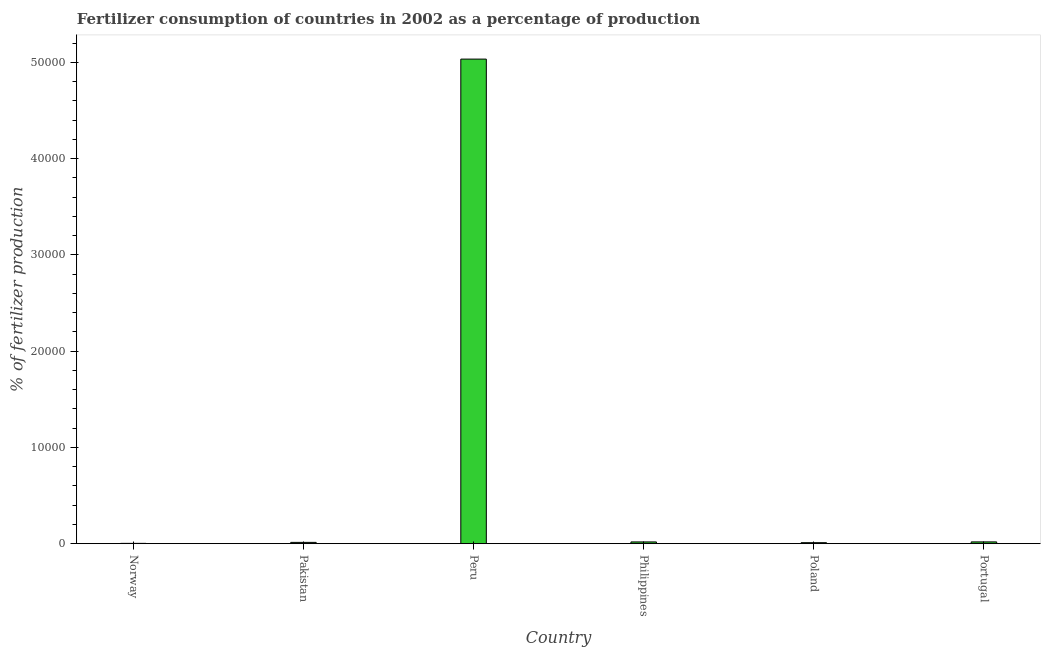What is the title of the graph?
Give a very brief answer. Fertilizer consumption of countries in 2002 as a percentage of production. What is the label or title of the X-axis?
Provide a succinct answer. Country. What is the label or title of the Y-axis?
Give a very brief answer. % of fertilizer production. What is the amount of fertilizer consumption in Norway?
Your answer should be compact. 30.19. Across all countries, what is the maximum amount of fertilizer consumption?
Your answer should be compact. 5.03e+04. Across all countries, what is the minimum amount of fertilizer consumption?
Your answer should be compact. 30.19. In which country was the amount of fertilizer consumption minimum?
Your answer should be very brief. Norway. What is the sum of the amount of fertilizer consumption?
Ensure brevity in your answer.  5.10e+04. What is the difference between the amount of fertilizer consumption in Norway and Portugal?
Your response must be concise. -152.18. What is the average amount of fertilizer consumption per country?
Make the answer very short. 8493.97. What is the median amount of fertilizer consumption?
Your answer should be very brief. 156.02. In how many countries, is the amount of fertilizer consumption greater than 38000 %?
Your answer should be very brief. 1. What is the ratio of the amount of fertilizer consumption in Pakistan to that in Peru?
Give a very brief answer. 0. Is the amount of fertilizer consumption in Philippines less than that in Poland?
Give a very brief answer. No. What is the difference between the highest and the second highest amount of fertilizer consumption?
Your answer should be very brief. 5.02e+04. Is the sum of the amount of fertilizer consumption in Philippines and Portugal greater than the maximum amount of fertilizer consumption across all countries?
Provide a succinct answer. No. What is the difference between the highest and the lowest amount of fertilizer consumption?
Provide a short and direct response. 5.03e+04. In how many countries, is the amount of fertilizer consumption greater than the average amount of fertilizer consumption taken over all countries?
Your answer should be very brief. 1. Are all the bars in the graph horizontal?
Provide a short and direct response. No. What is the difference between two consecutive major ticks on the Y-axis?
Make the answer very short. 10000. What is the % of fertilizer production in Norway?
Offer a very short reply. 30.19. What is the % of fertilizer production in Pakistan?
Your response must be concise. 132.13. What is the % of fertilizer production in Peru?
Make the answer very short. 5.03e+04. What is the % of fertilizer production of Philippines?
Provide a succinct answer. 179.9. What is the % of fertilizer production of Poland?
Provide a short and direct response. 102.4. What is the % of fertilizer production of Portugal?
Ensure brevity in your answer.  182.38. What is the difference between the % of fertilizer production in Norway and Pakistan?
Keep it short and to the point. -101.94. What is the difference between the % of fertilizer production in Norway and Peru?
Give a very brief answer. -5.03e+04. What is the difference between the % of fertilizer production in Norway and Philippines?
Your response must be concise. -149.71. What is the difference between the % of fertilizer production in Norway and Poland?
Your response must be concise. -72.21. What is the difference between the % of fertilizer production in Norway and Portugal?
Your answer should be compact. -152.18. What is the difference between the % of fertilizer production in Pakistan and Peru?
Provide a succinct answer. -5.02e+04. What is the difference between the % of fertilizer production in Pakistan and Philippines?
Your response must be concise. -47.77. What is the difference between the % of fertilizer production in Pakistan and Poland?
Provide a short and direct response. 29.73. What is the difference between the % of fertilizer production in Pakistan and Portugal?
Offer a very short reply. -50.24. What is the difference between the % of fertilizer production in Peru and Philippines?
Your answer should be compact. 5.02e+04. What is the difference between the % of fertilizer production in Peru and Poland?
Make the answer very short. 5.02e+04. What is the difference between the % of fertilizer production in Peru and Portugal?
Offer a terse response. 5.02e+04. What is the difference between the % of fertilizer production in Philippines and Poland?
Offer a terse response. 77.5. What is the difference between the % of fertilizer production in Philippines and Portugal?
Provide a short and direct response. -2.48. What is the difference between the % of fertilizer production in Poland and Portugal?
Provide a short and direct response. -79.97. What is the ratio of the % of fertilizer production in Norway to that in Pakistan?
Offer a terse response. 0.23. What is the ratio of the % of fertilizer production in Norway to that in Peru?
Offer a very short reply. 0. What is the ratio of the % of fertilizer production in Norway to that in Philippines?
Ensure brevity in your answer.  0.17. What is the ratio of the % of fertilizer production in Norway to that in Poland?
Make the answer very short. 0.29. What is the ratio of the % of fertilizer production in Norway to that in Portugal?
Your response must be concise. 0.17. What is the ratio of the % of fertilizer production in Pakistan to that in Peru?
Your response must be concise. 0. What is the ratio of the % of fertilizer production in Pakistan to that in Philippines?
Your response must be concise. 0.73. What is the ratio of the % of fertilizer production in Pakistan to that in Poland?
Provide a succinct answer. 1.29. What is the ratio of the % of fertilizer production in Pakistan to that in Portugal?
Ensure brevity in your answer.  0.72. What is the ratio of the % of fertilizer production in Peru to that in Philippines?
Offer a very short reply. 279.81. What is the ratio of the % of fertilizer production in Peru to that in Poland?
Offer a terse response. 491.56. What is the ratio of the % of fertilizer production in Peru to that in Portugal?
Offer a very short reply. 276. What is the ratio of the % of fertilizer production in Philippines to that in Poland?
Provide a short and direct response. 1.76. What is the ratio of the % of fertilizer production in Poland to that in Portugal?
Your answer should be compact. 0.56. 